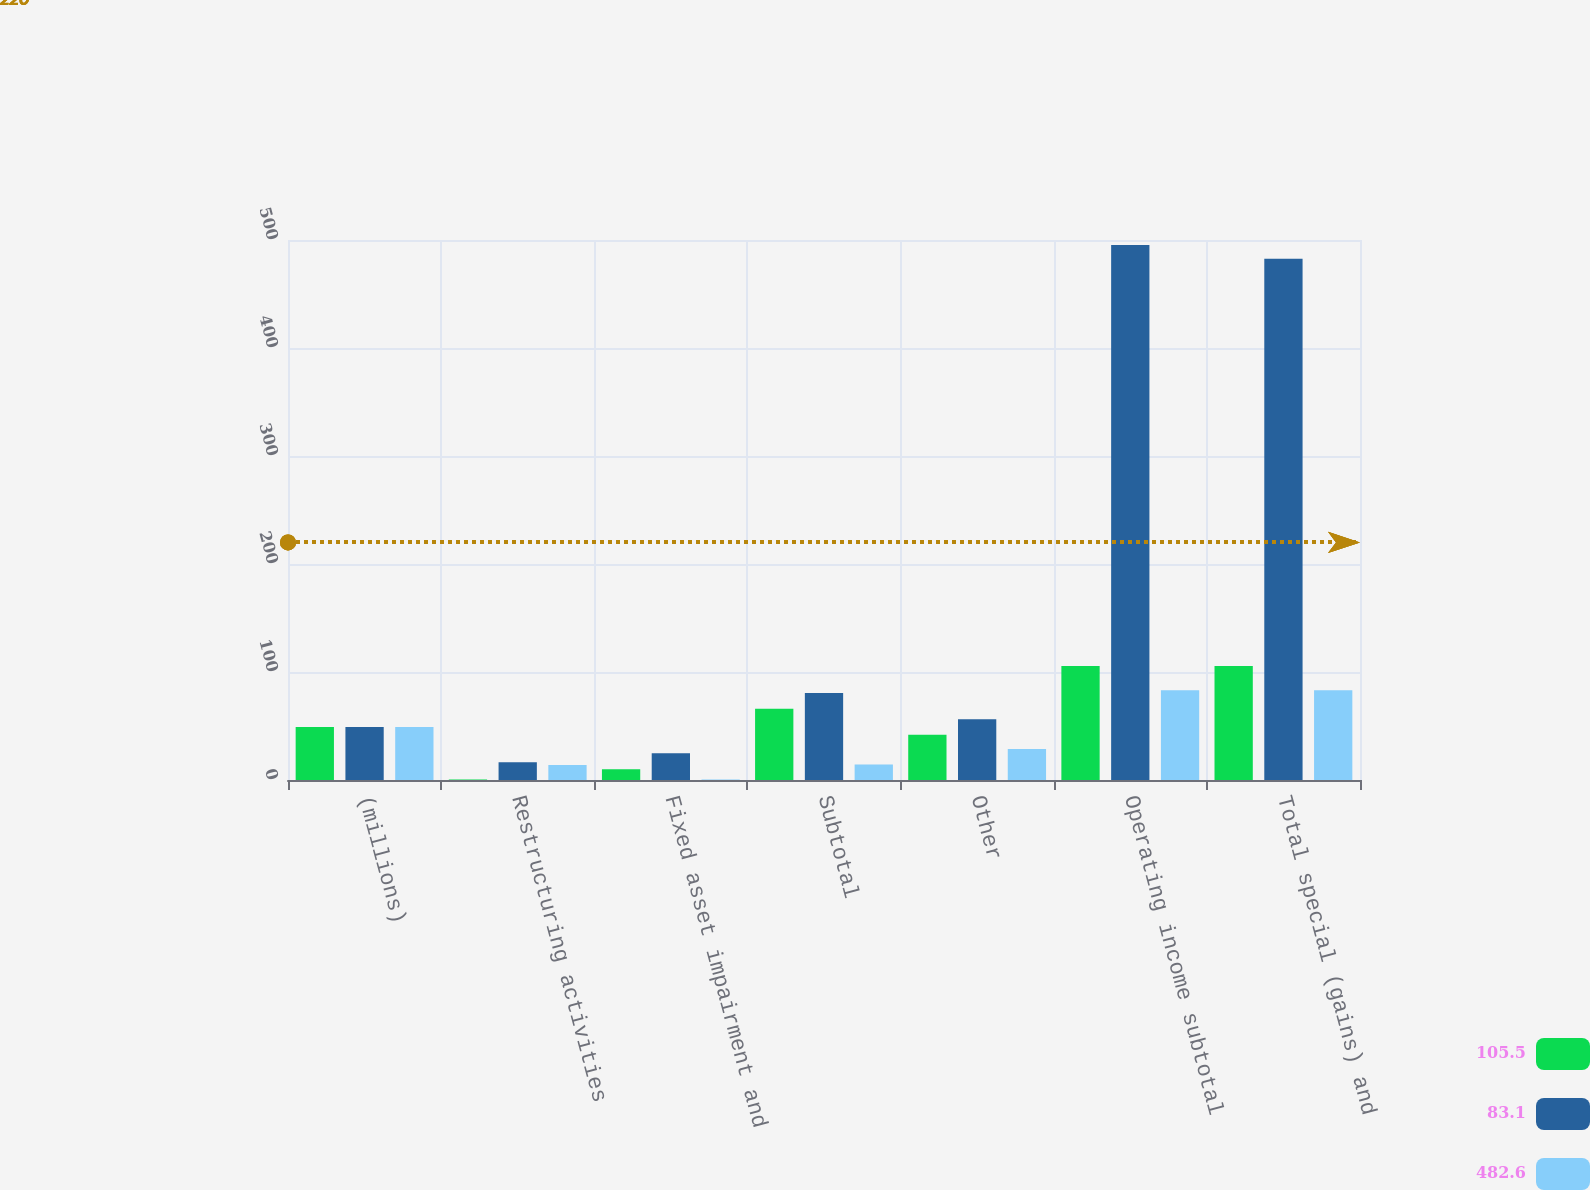<chart> <loc_0><loc_0><loc_500><loc_500><stacked_bar_chart><ecel><fcel>(millions)<fcel>Restructuring activities<fcel>Fixed asset impairment and<fcel>Subtotal<fcel>Other<fcel>Operating income subtotal<fcel>Total special (gains) and<nl><fcel>105.5<fcel>49.05<fcel>0.4<fcel>10<fcel>66<fcel>41.8<fcel>105.5<fcel>105.5<nl><fcel>83.1<fcel>49.05<fcel>16.5<fcel>24.7<fcel>80.6<fcel>56.3<fcel>495.4<fcel>482.6<nl><fcel>482.6<fcel>49.05<fcel>13.9<fcel>0.4<fcel>14.3<fcel>28.8<fcel>83.1<fcel>83.1<nl></chart> 